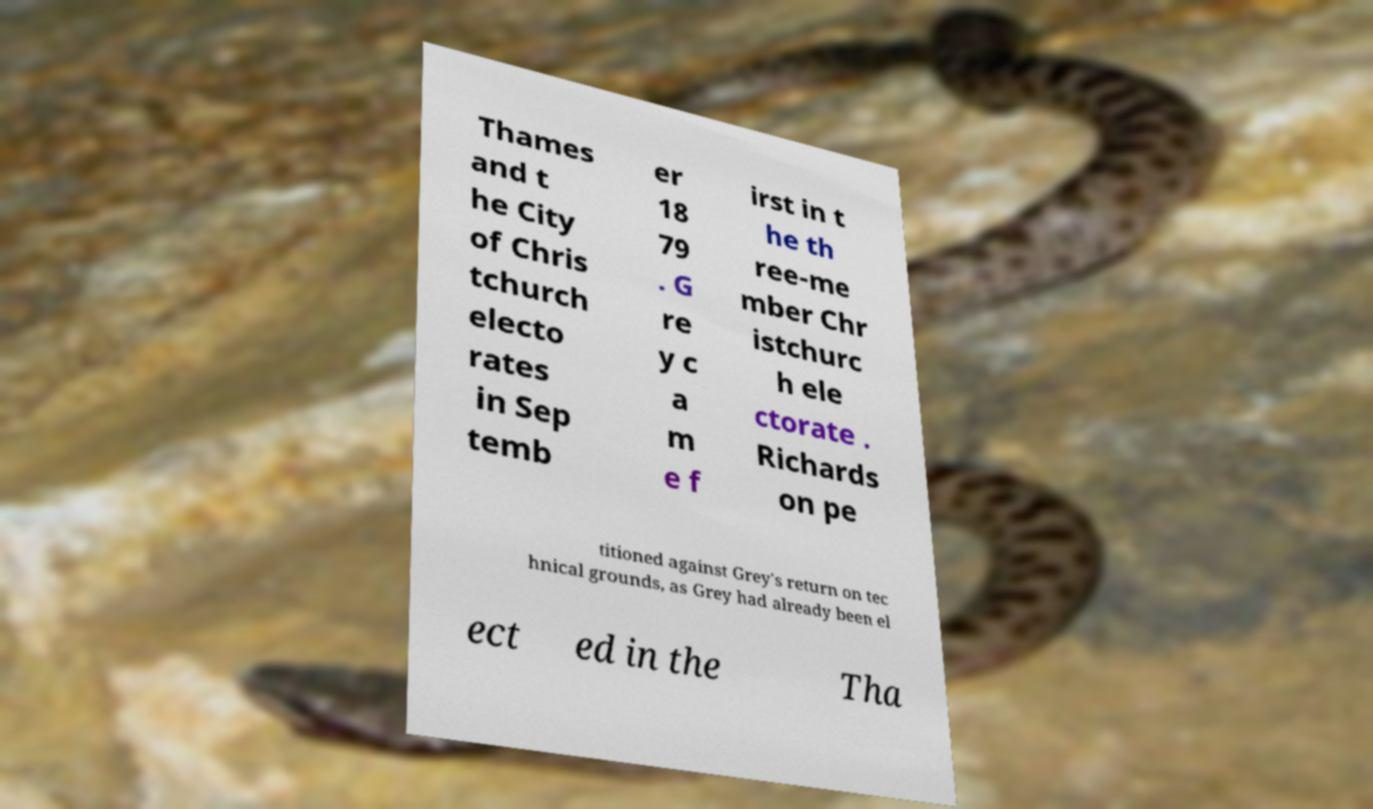There's text embedded in this image that I need extracted. Can you transcribe it verbatim? Thames and t he City of Chris tchurch electo rates in Sep temb er 18 79 . G re y c a m e f irst in t he th ree-me mber Chr istchurc h ele ctorate . Richards on pe titioned against Grey's return on tec hnical grounds, as Grey had already been el ect ed in the Tha 